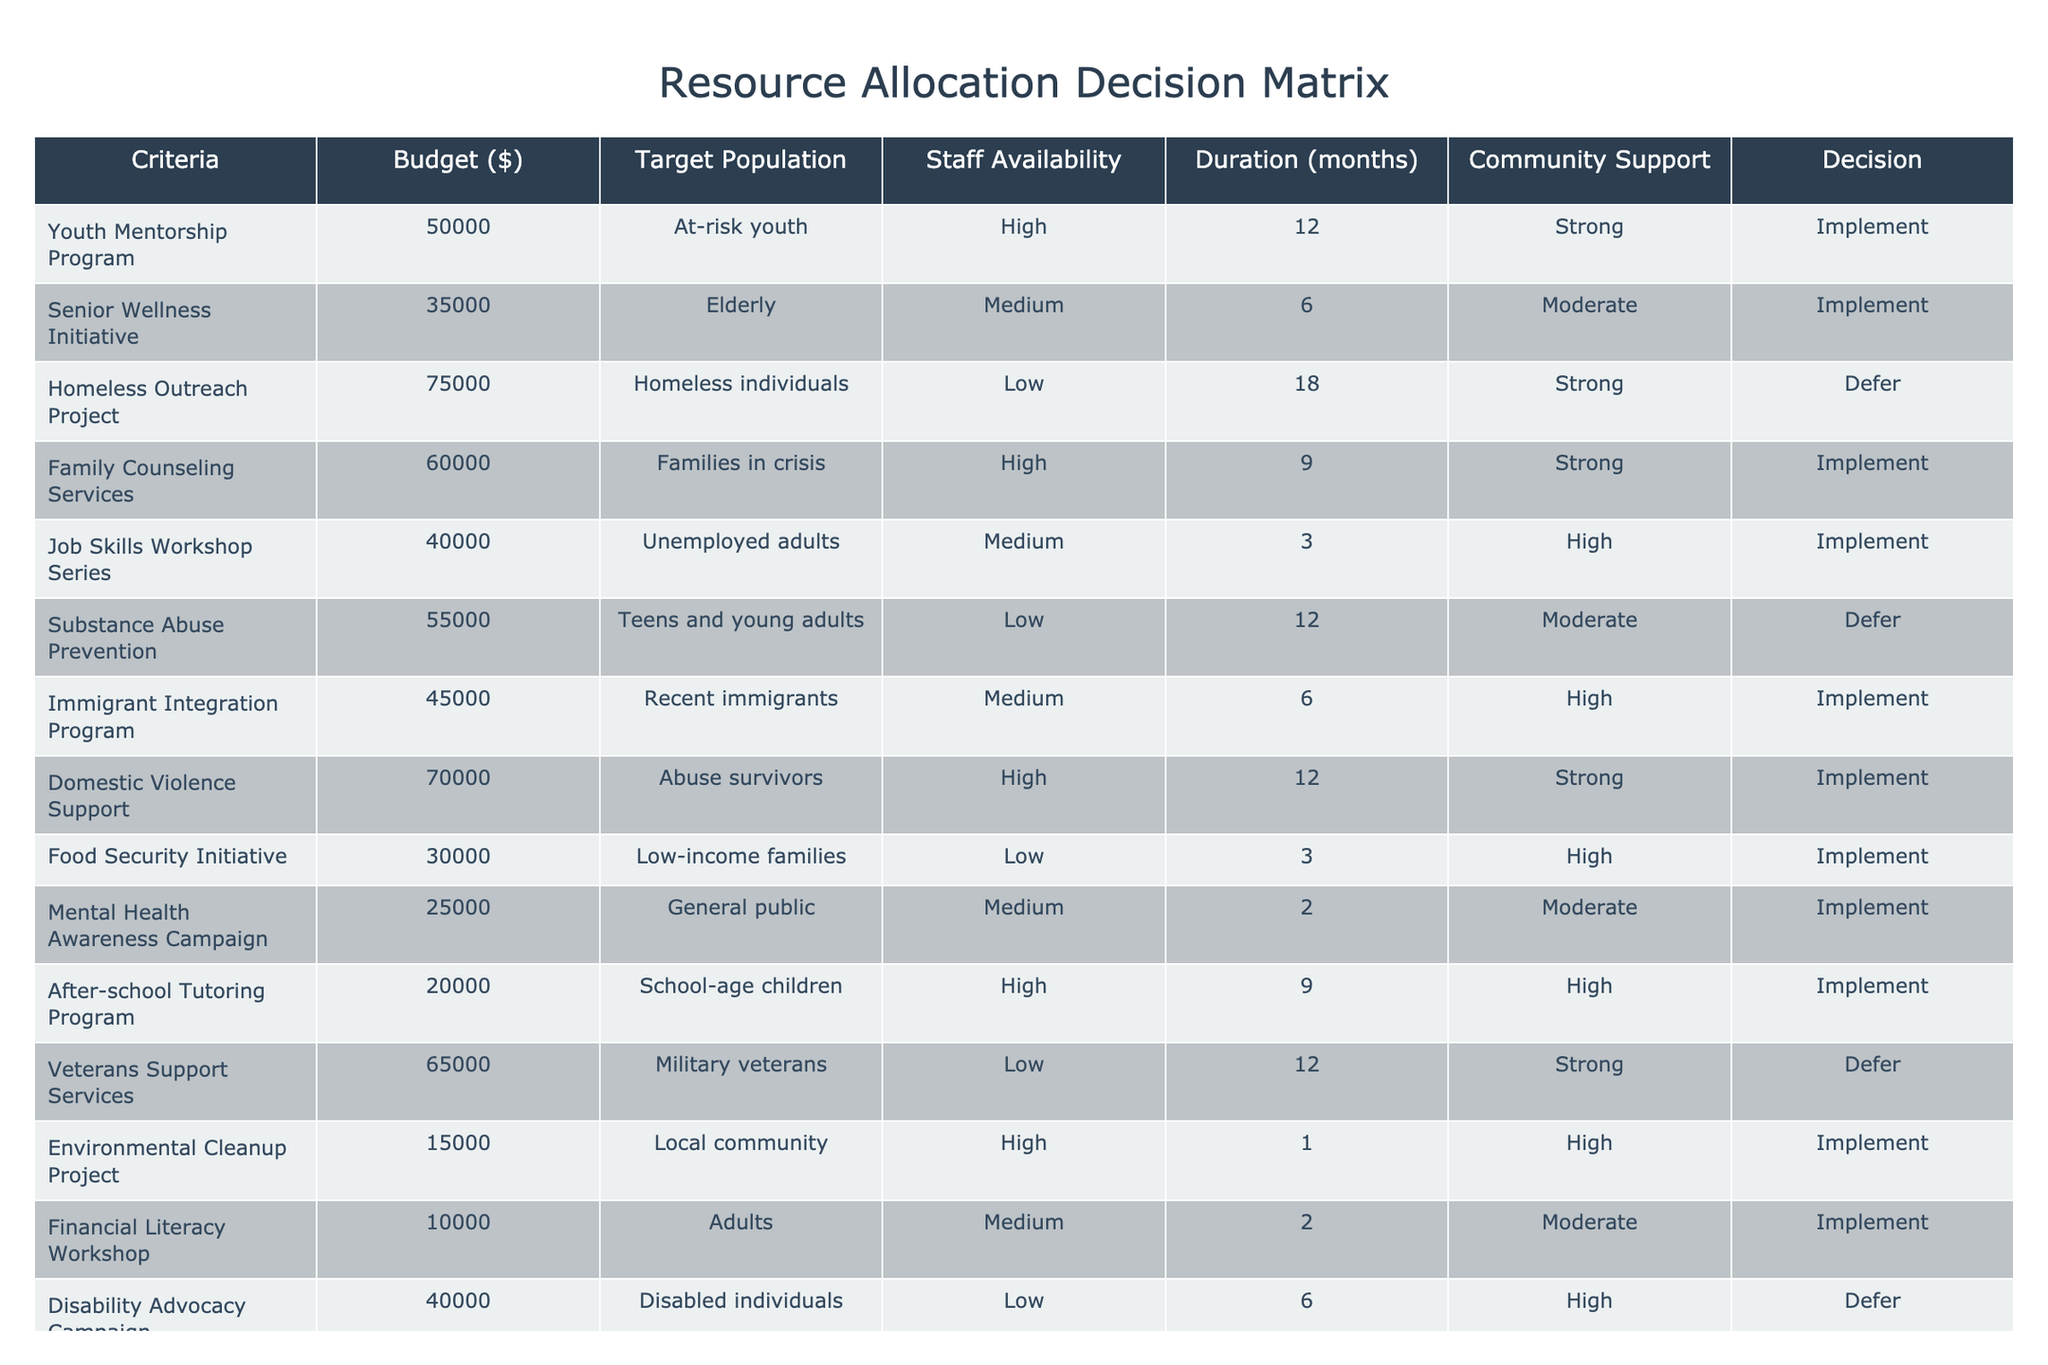What is the budget allocated for the Youth Mentorship Program? The table shows that the budget for the Youth Mentorship Program is listed in the corresponding row under the Budget column. By checking the row, we can see it states 50,000.
Answer: 50000 How many programs are recommended for implementation? To find the number of programs recommended for implementation, we can count the rows where the Decision column states "Implement." By looking at the table, those programs are Youth Mentorship Program, Senior Wellness Initiative, Family Counseling Services, Job Skills Workshop Series, Immigrant Integration Program, Domestic Violence Support, Food Security Initiative, Mental Health Awareness Campaign, After-school Tutoring Program, and Financial Literacy Workshop, giving us a total of 9 programs.
Answer: 9 Are there any programs targeting homeless individuals? We can look for the row in the table that specifies "Homeless individuals" in the Target Population column. By checking the entries, we find the Homeless Outreach Project is the only entry with that target population, and the Decision for this project is "Defer."
Answer: Yes What is the average budget of the programs that are planned to be implemented? We first identify the budgets for all programs marked as "Implement": 50,000 (Youth Mentorship Program), 35,000 (Senior Wellness Initiative), 60,000 (Family Counseling Services), 40,000 (Job Skills Workshop Series), 45,000 (Immigrant Integration Program), 70,000 (Domestic Violence Support), 30,000 (Food Security Initiative), 25,000 (Mental Health Awareness Campaign), 20,000 (After-school Tutoring Program), and 10,000 (Financial Literacy Workshop). The total of these budgets is 50,000 + 35,000 + 60,000 + 40,000 + 45,000 + 70,000 + 30,000 + 25,000 + 20,000 + 10,000 = 420,000. Since there are 9 programs, we divide this sum by 9, yielding an average of 420,000 / 9 = 46,666.67.
Answer: 46666.67 Is the duration for the Environmental Cleanup Project shorter than that of the Substance Abuse Prevention program? We check the duration for both programs in the table. The Environmental Cleanup Project has a duration of 1 month, and the Substance Abuse Prevention program has a duration of 12 months. Since 1 is less than 12, the duration for the Environmental Cleanup Project is indeed shorter.
Answer: Yes What is the decision status of the program with the highest budget? We look for the highest budget listed in the table. The Homeless Outreach Project has the highest budget of 75,000. The corresponding decision in the Decision column is "Defer." Thus, the status of this program is to defer.
Answer: Defer 